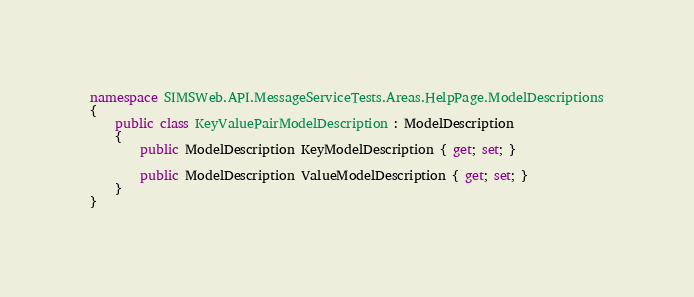Convert code to text. <code><loc_0><loc_0><loc_500><loc_500><_C#_>namespace SIMSWeb.API.MessageServiceTests.Areas.HelpPage.ModelDescriptions
{
    public class KeyValuePairModelDescription : ModelDescription
    {
        public ModelDescription KeyModelDescription { get; set; }

        public ModelDescription ValueModelDescription { get; set; }
    }
}</code> 